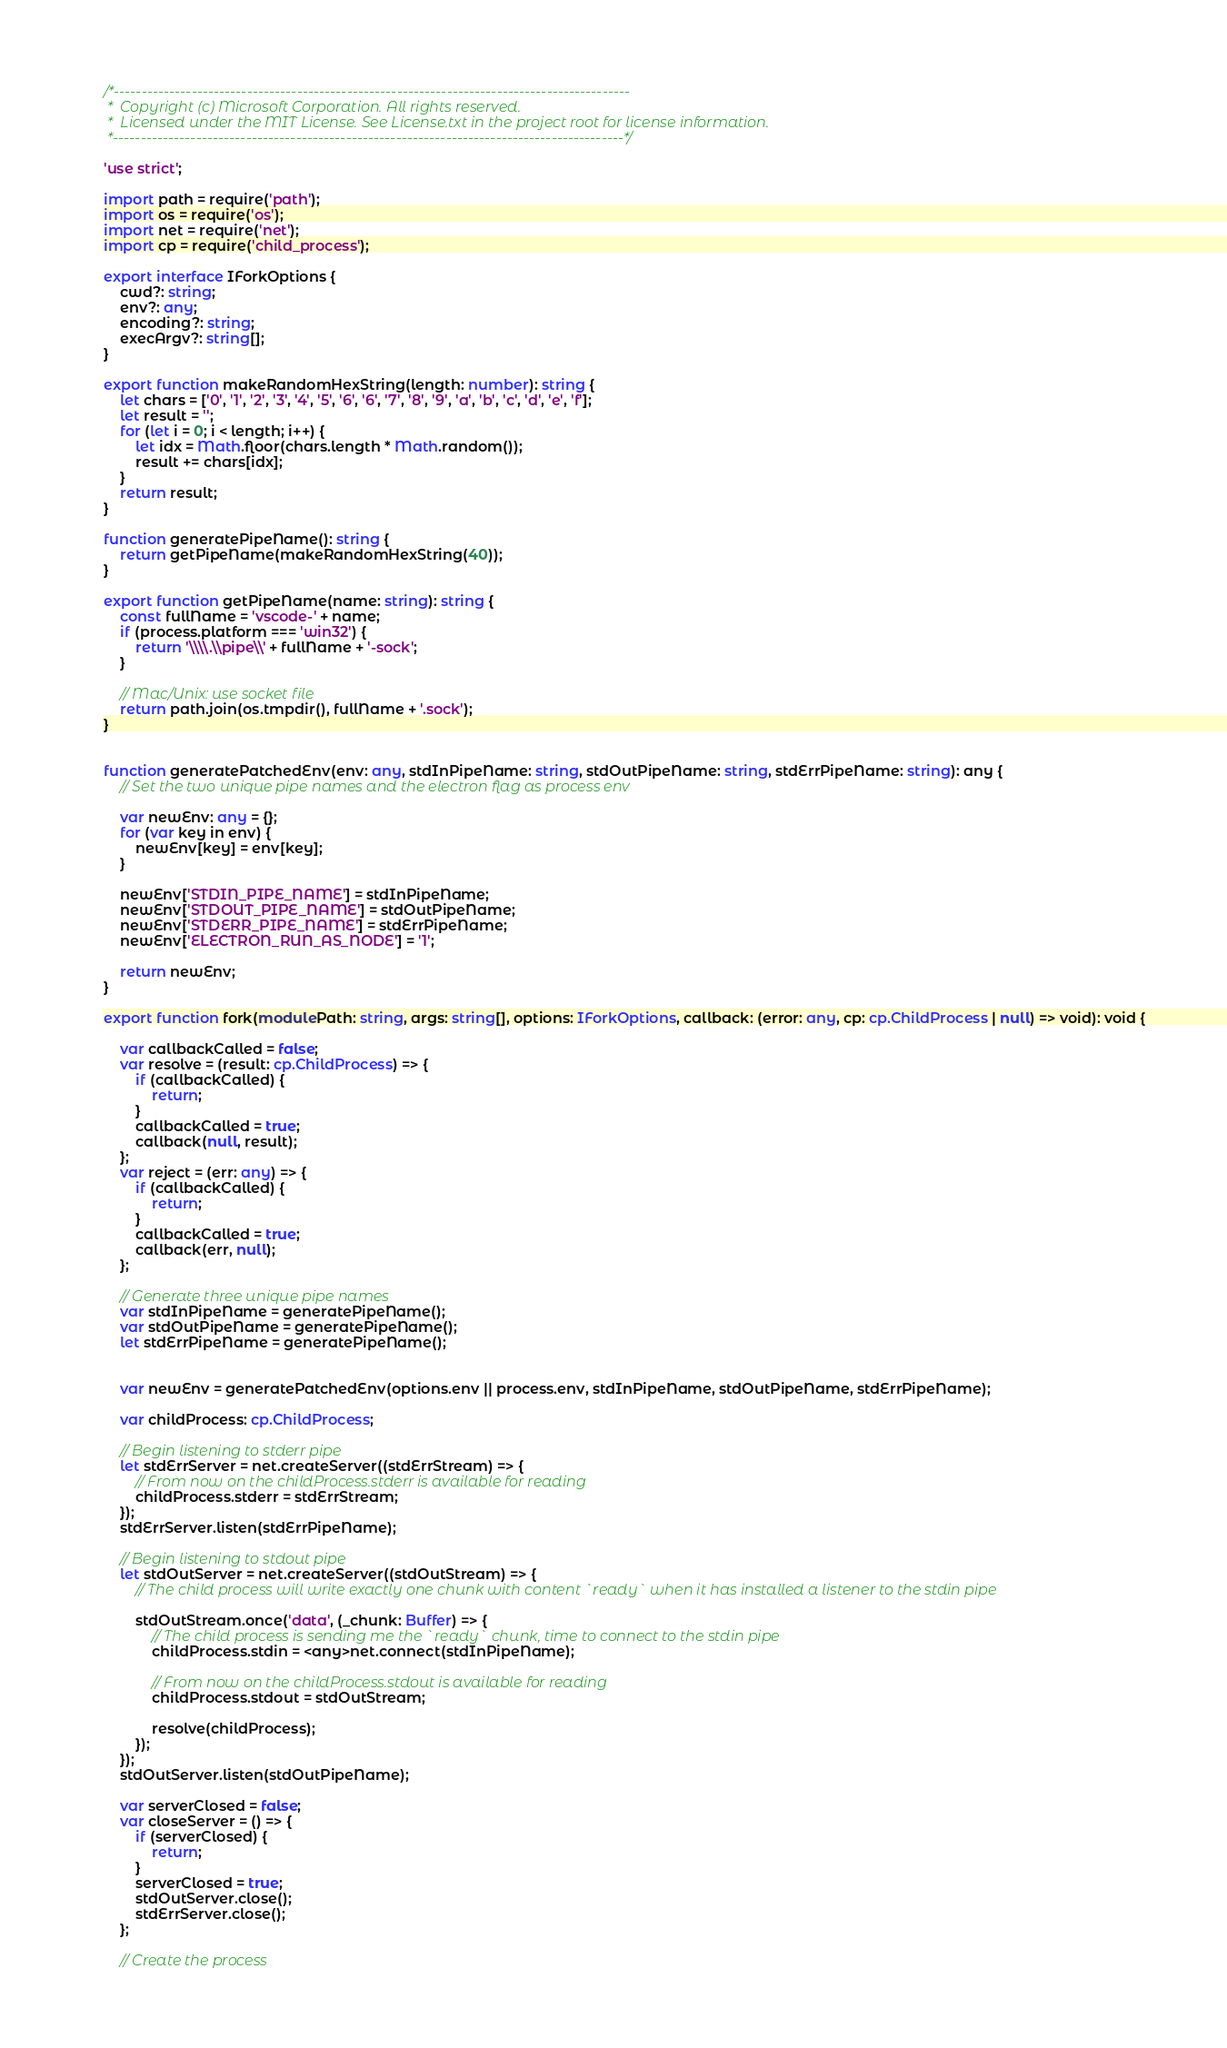Convert code to text. <code><loc_0><loc_0><loc_500><loc_500><_TypeScript_>/*---------------------------------------------------------------------------------------------
 *  Copyright (c) Microsoft Corporation. All rights reserved.
 *  Licensed under the MIT License. See License.txt in the project root for license information.
 *--------------------------------------------------------------------------------------------*/

'use strict';

import path = require('path');
import os = require('os');
import net = require('net');
import cp = require('child_process');

export interface IForkOptions {
	cwd?: string;
	env?: any;
	encoding?: string;
	execArgv?: string[];
}

export function makeRandomHexString(length: number): string {
	let chars = ['0', '1', '2', '3', '4', '5', '6', '6', '7', '8', '9', 'a', 'b', 'c', 'd', 'e', 'f'];
	let result = '';
	for (let i = 0; i < length; i++) {
		let idx = Math.floor(chars.length * Math.random());
		result += chars[idx];
	}
	return result;
}

function generatePipeName(): string {
	return getPipeName(makeRandomHexString(40));
}

export function getPipeName(name: string): string {
	const fullName = 'vscode-' + name;
	if (process.platform === 'win32') {
		return '\\\\.\\pipe\\' + fullName + '-sock';
	}

	// Mac/Unix: use socket file
	return path.join(os.tmpdir(), fullName + '.sock');
}


function generatePatchedEnv(env: any, stdInPipeName: string, stdOutPipeName: string, stdErrPipeName: string): any {
	// Set the two unique pipe names and the electron flag as process env

	var newEnv: any = {};
	for (var key in env) {
		newEnv[key] = env[key];
	}

	newEnv['STDIN_PIPE_NAME'] = stdInPipeName;
	newEnv['STDOUT_PIPE_NAME'] = stdOutPipeName;
	newEnv['STDERR_PIPE_NAME'] = stdErrPipeName;
	newEnv['ELECTRON_RUN_AS_NODE'] = '1';

	return newEnv;
}

export function fork(modulePath: string, args: string[], options: IForkOptions, callback: (error: any, cp: cp.ChildProcess | null) => void): void {

	var callbackCalled = false;
	var resolve = (result: cp.ChildProcess) => {
		if (callbackCalled) {
			return;
		}
		callbackCalled = true;
		callback(null, result);
	};
	var reject = (err: any) => {
		if (callbackCalled) {
			return;
		}
		callbackCalled = true;
		callback(err, null);
	};

	// Generate three unique pipe names
	var stdInPipeName = generatePipeName();
	var stdOutPipeName = generatePipeName();
	let stdErrPipeName = generatePipeName();


	var newEnv = generatePatchedEnv(options.env || process.env, stdInPipeName, stdOutPipeName, stdErrPipeName);

	var childProcess: cp.ChildProcess;

	// Begin listening to stderr pipe
	let stdErrServer = net.createServer((stdErrStream) => {
		// From now on the childProcess.stderr is available for reading
		childProcess.stderr = stdErrStream;
	});
	stdErrServer.listen(stdErrPipeName);

	// Begin listening to stdout pipe
	let stdOutServer = net.createServer((stdOutStream) => {
		// The child process will write exactly one chunk with content `ready` when it has installed a listener to the stdin pipe

		stdOutStream.once('data', (_chunk: Buffer) => {
			// The child process is sending me the `ready` chunk, time to connect to the stdin pipe
			childProcess.stdin = <any>net.connect(stdInPipeName);

			// From now on the childProcess.stdout is available for reading
			childProcess.stdout = stdOutStream;

			resolve(childProcess);
		});
	});
	stdOutServer.listen(stdOutPipeName);

	var serverClosed = false;
	var closeServer = () => {
		if (serverClosed) {
			return;
		}
		serverClosed = true;
		stdOutServer.close();
		stdErrServer.close();
	};

	// Create the process</code> 